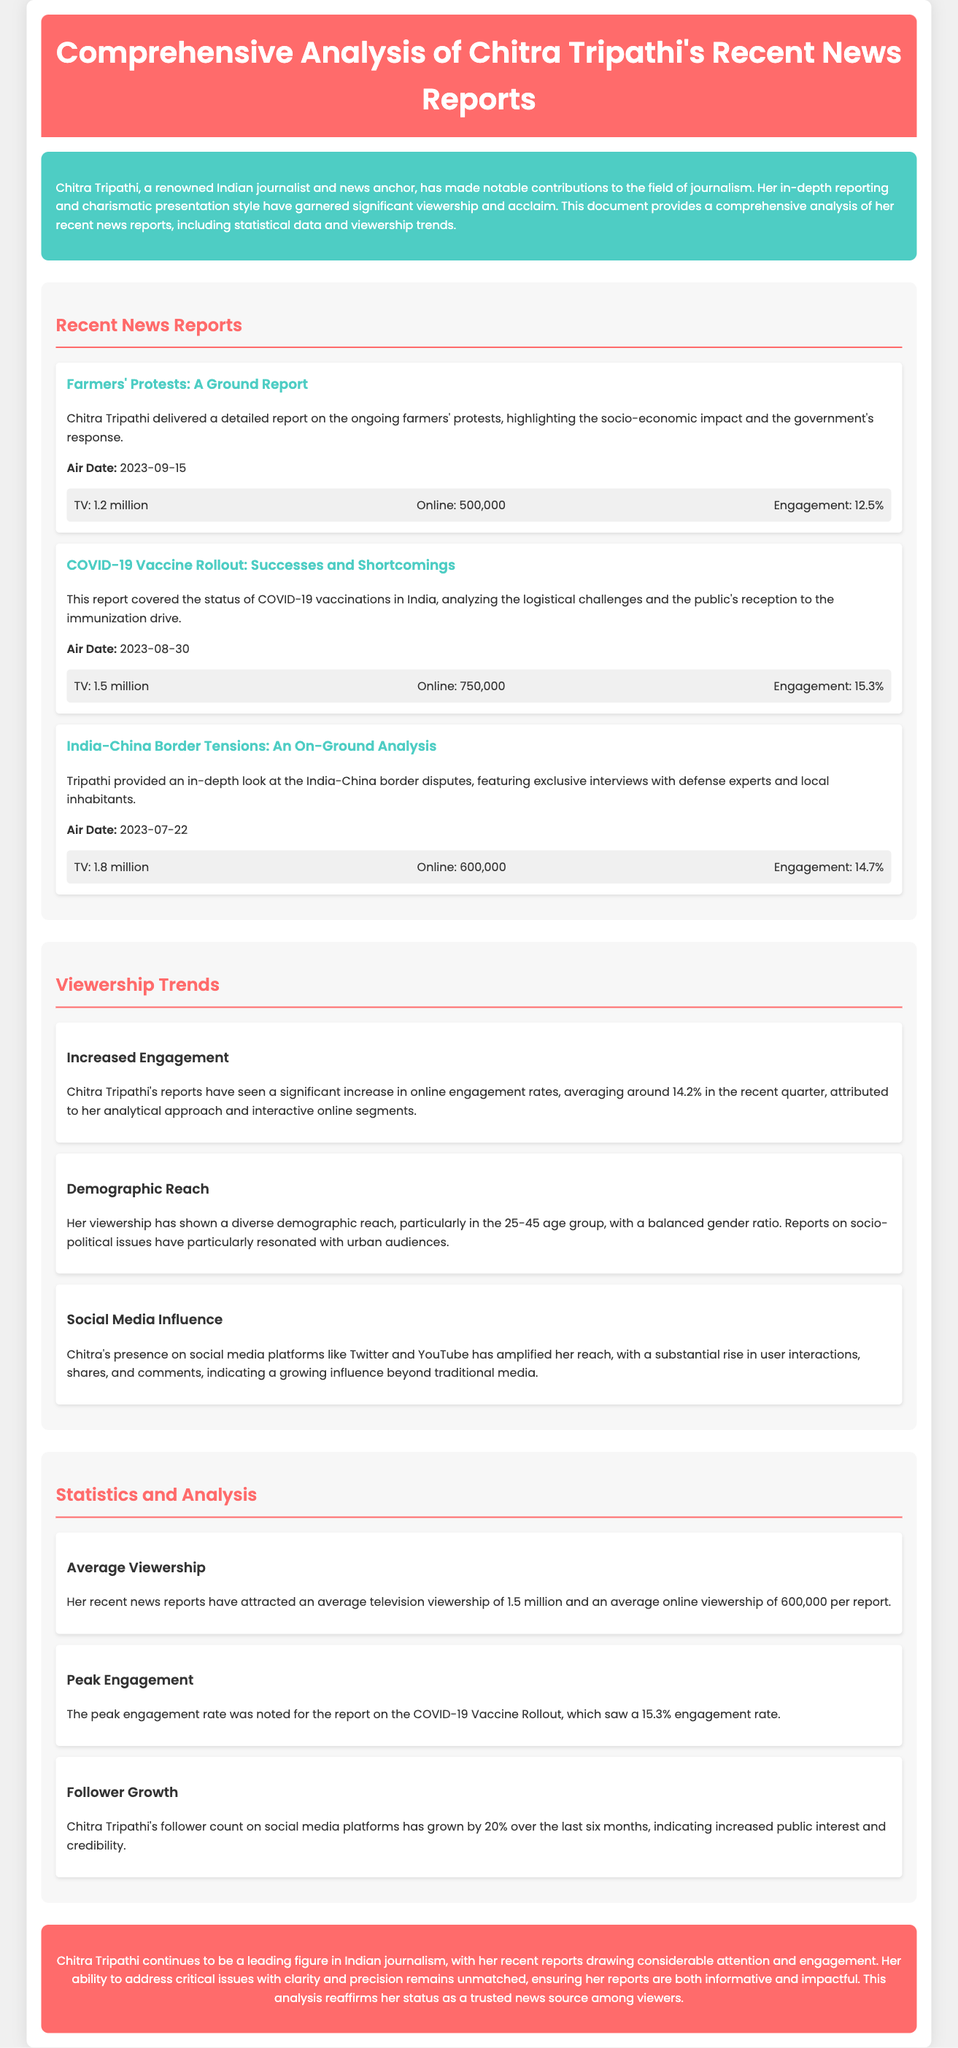What was the air date of the report on farmers' protests? The air date is mentioned in the document under the report's details, specifically for the "Farmers' Protests: A Ground Report."
Answer: 2023-09-15 What was the engagement rate of the COVID-19 Vaccine Rollout report? The engagement rate for the COVID-19 Vaccine Rollout report is highlighted in its viewership section.
Answer: 15.3% How many million viewers watched the India-China Border Tensions report on TV? The number of viewers is provided in the viewership section of the report details for "India-China Border Tensions: An On-Ground Analysis."
Answer: 1.8 million What percentage has Chitra Tripathi's follower count grown over the last six months? The growth percentage of her follower count is stated in the statistics section regarding social media influence.
Answer: 20% What is the average television viewership of Chitra Tripathi's recent news reports? The average television viewership is mentioned in the statistics and analysis section of the document.
Answer: 1.5 million Which age group is primarily targeted by Chitra Tripathi's viewership? The demographic reach detailing targeted age groups is mentioned in the viewership trends section of the document.
Answer: 25-45 age group What color is used for the header background? The background color of the header is described in the styling details of the document.
Answer: #ff6b6b What topic was covered in Chitra Tripathi's report on August 30, 2023? The report from August 30, 2023 is explicitly titled in the recent news reports section.
Answer: COVID-19 Vaccine Rollout What is the trend regarding social media interactions mentioned in the document? The document discusses social media influence, indicating the increase in interactions, shares, and comments.
Answer: Growing influence 